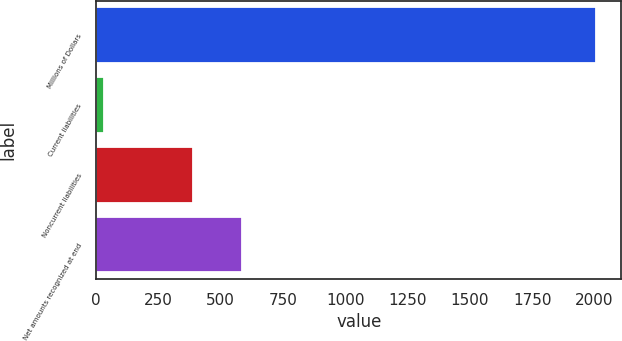Convert chart to OTSL. <chart><loc_0><loc_0><loc_500><loc_500><bar_chart><fcel>Millions of Dollars<fcel>Current liabilities<fcel>Noncurrent liabilities<fcel>Net amounts recognized at end<nl><fcel>2008<fcel>30<fcel>388<fcel>585.8<nl></chart> 